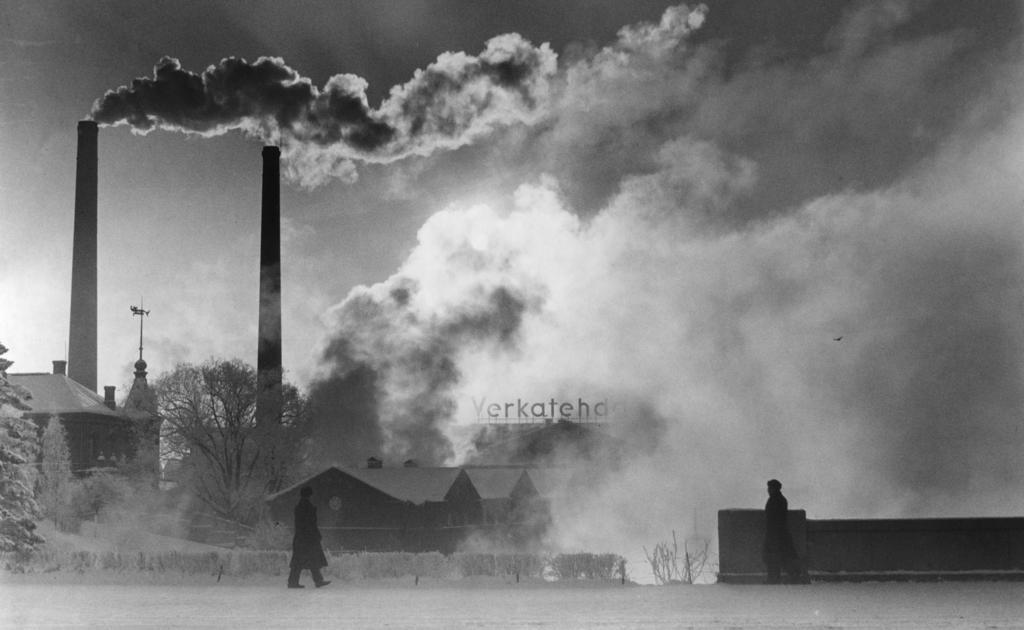Please provide a concise description of this image. At the bottom of the image we can see two people walking. In the center there are seeds and trees. In the background there are chimneys and we can see smoke. At the top there is sky. 